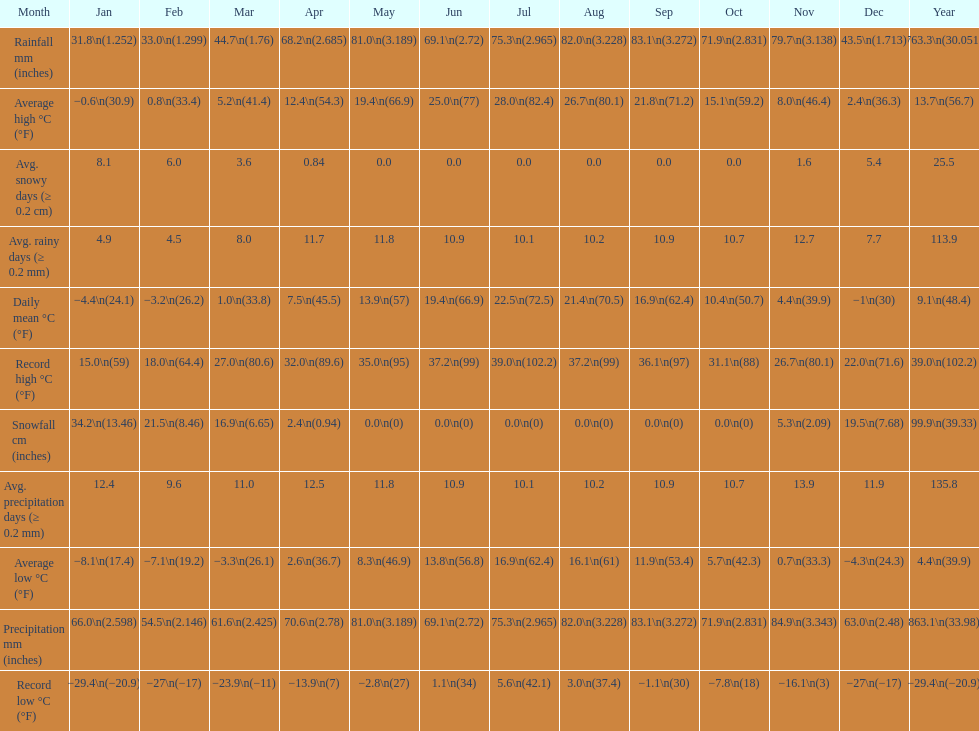How many months had a record high of over 15.0 degrees? 11. 